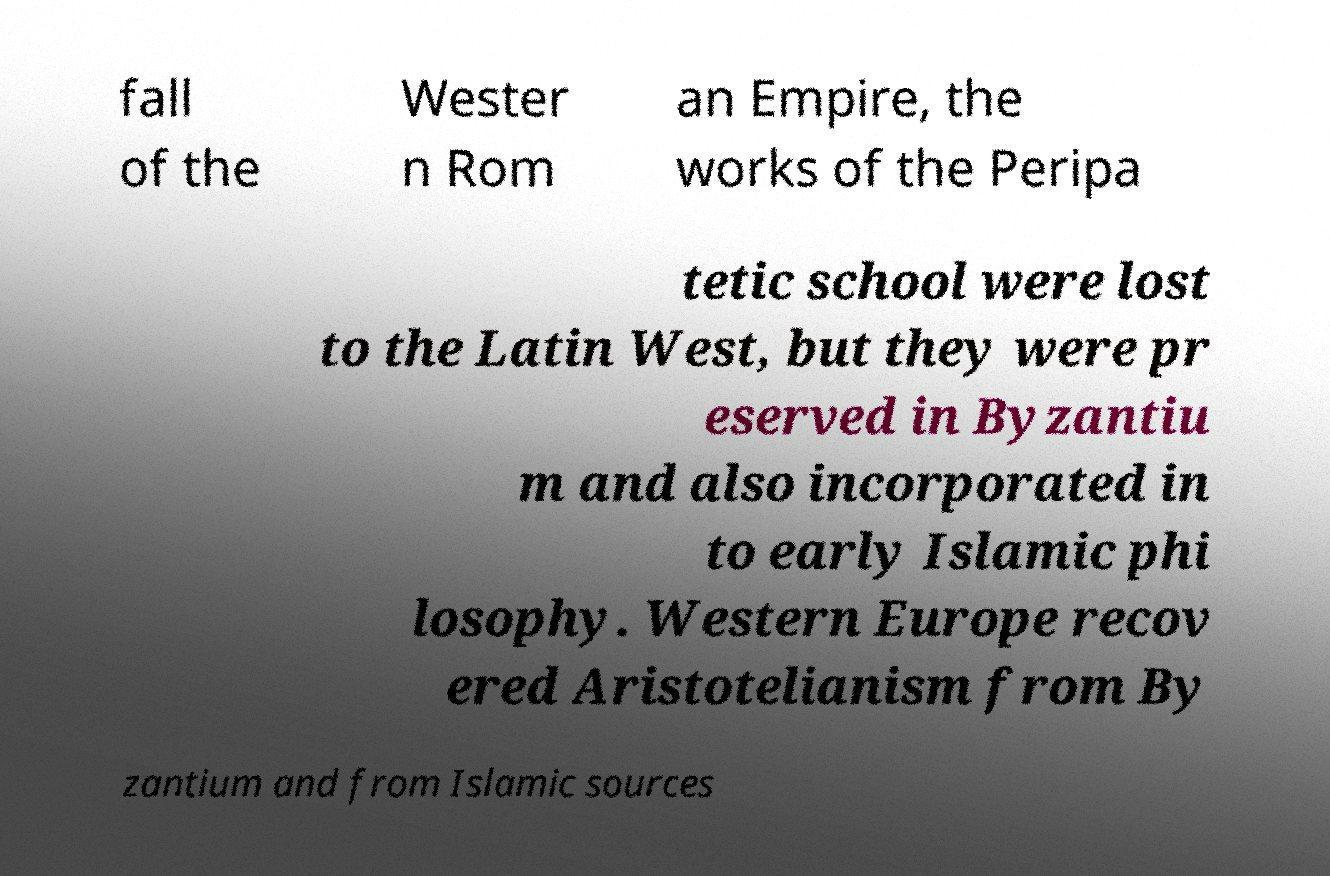Could you assist in decoding the text presented in this image and type it out clearly? fall of the Wester n Rom an Empire, the works of the Peripa tetic school were lost to the Latin West, but they were pr eserved in Byzantiu m and also incorporated in to early Islamic phi losophy. Western Europe recov ered Aristotelianism from By zantium and from Islamic sources 